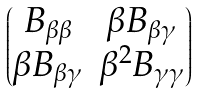Convert formula to latex. <formula><loc_0><loc_0><loc_500><loc_500>\begin{pmatrix} B _ { \beta \beta } & \beta B _ { \beta \gamma } \\ \beta B _ { \beta \gamma } & \beta ^ { 2 } B _ { \gamma \gamma } \end{pmatrix}</formula> 